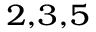Convert formula to latex. <formula><loc_0><loc_0><loc_500><loc_500>{ } ^ { 2 , 3 , 5 }</formula> 